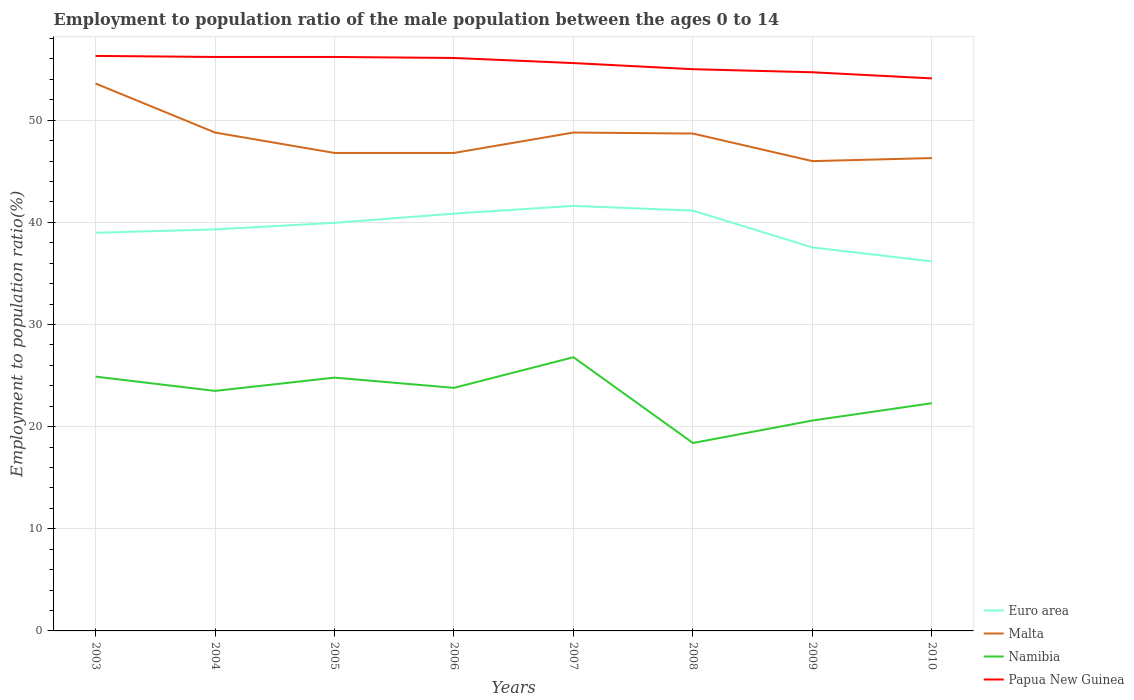Does the line corresponding to Euro area intersect with the line corresponding to Namibia?
Your answer should be compact. No. Across all years, what is the maximum employment to population ratio in Euro area?
Ensure brevity in your answer.  36.18. In which year was the employment to population ratio in Euro area maximum?
Keep it short and to the point. 2010. What is the total employment to population ratio in Papua New Guinea in the graph?
Keep it short and to the point. 0.1. What is the difference between the highest and the second highest employment to population ratio in Malta?
Offer a very short reply. 7.6. How many years are there in the graph?
Ensure brevity in your answer.  8. What is the difference between two consecutive major ticks on the Y-axis?
Your response must be concise. 10. Are the values on the major ticks of Y-axis written in scientific E-notation?
Offer a terse response. No. Does the graph contain grids?
Your answer should be very brief. Yes. How many legend labels are there?
Offer a terse response. 4. How are the legend labels stacked?
Offer a very short reply. Vertical. What is the title of the graph?
Provide a succinct answer. Employment to population ratio of the male population between the ages 0 to 14. What is the label or title of the X-axis?
Keep it short and to the point. Years. What is the label or title of the Y-axis?
Your answer should be compact. Employment to population ratio(%). What is the Employment to population ratio(%) in Euro area in 2003?
Provide a succinct answer. 38.98. What is the Employment to population ratio(%) in Malta in 2003?
Your answer should be very brief. 53.6. What is the Employment to population ratio(%) of Namibia in 2003?
Offer a terse response. 24.9. What is the Employment to population ratio(%) in Papua New Guinea in 2003?
Make the answer very short. 56.3. What is the Employment to population ratio(%) of Euro area in 2004?
Keep it short and to the point. 39.31. What is the Employment to population ratio(%) of Malta in 2004?
Provide a succinct answer. 48.8. What is the Employment to population ratio(%) of Namibia in 2004?
Provide a succinct answer. 23.5. What is the Employment to population ratio(%) in Papua New Guinea in 2004?
Your answer should be compact. 56.2. What is the Employment to population ratio(%) in Euro area in 2005?
Ensure brevity in your answer.  39.96. What is the Employment to population ratio(%) of Malta in 2005?
Your answer should be very brief. 46.8. What is the Employment to population ratio(%) in Namibia in 2005?
Your answer should be very brief. 24.8. What is the Employment to population ratio(%) of Papua New Guinea in 2005?
Your response must be concise. 56.2. What is the Employment to population ratio(%) of Euro area in 2006?
Your answer should be very brief. 40.86. What is the Employment to population ratio(%) in Malta in 2006?
Provide a short and direct response. 46.8. What is the Employment to population ratio(%) in Namibia in 2006?
Make the answer very short. 23.8. What is the Employment to population ratio(%) of Papua New Guinea in 2006?
Your response must be concise. 56.1. What is the Employment to population ratio(%) in Euro area in 2007?
Your answer should be very brief. 41.62. What is the Employment to population ratio(%) in Malta in 2007?
Provide a succinct answer. 48.8. What is the Employment to population ratio(%) of Namibia in 2007?
Offer a very short reply. 26.8. What is the Employment to population ratio(%) of Papua New Guinea in 2007?
Your response must be concise. 55.6. What is the Employment to population ratio(%) of Euro area in 2008?
Give a very brief answer. 41.15. What is the Employment to population ratio(%) of Malta in 2008?
Give a very brief answer. 48.7. What is the Employment to population ratio(%) in Namibia in 2008?
Give a very brief answer. 18.4. What is the Employment to population ratio(%) of Euro area in 2009?
Your answer should be compact. 37.55. What is the Employment to population ratio(%) in Namibia in 2009?
Offer a terse response. 20.6. What is the Employment to population ratio(%) of Papua New Guinea in 2009?
Provide a succinct answer. 54.7. What is the Employment to population ratio(%) in Euro area in 2010?
Your response must be concise. 36.18. What is the Employment to population ratio(%) in Malta in 2010?
Make the answer very short. 46.3. What is the Employment to population ratio(%) in Namibia in 2010?
Provide a succinct answer. 22.3. What is the Employment to population ratio(%) of Papua New Guinea in 2010?
Offer a terse response. 54.1. Across all years, what is the maximum Employment to population ratio(%) in Euro area?
Offer a terse response. 41.62. Across all years, what is the maximum Employment to population ratio(%) of Malta?
Your response must be concise. 53.6. Across all years, what is the maximum Employment to population ratio(%) in Namibia?
Ensure brevity in your answer.  26.8. Across all years, what is the maximum Employment to population ratio(%) of Papua New Guinea?
Provide a succinct answer. 56.3. Across all years, what is the minimum Employment to population ratio(%) in Euro area?
Your response must be concise. 36.18. Across all years, what is the minimum Employment to population ratio(%) in Malta?
Keep it short and to the point. 46. Across all years, what is the minimum Employment to population ratio(%) of Namibia?
Provide a succinct answer. 18.4. Across all years, what is the minimum Employment to population ratio(%) of Papua New Guinea?
Make the answer very short. 54.1. What is the total Employment to population ratio(%) in Euro area in the graph?
Provide a succinct answer. 315.61. What is the total Employment to population ratio(%) of Malta in the graph?
Provide a succinct answer. 385.8. What is the total Employment to population ratio(%) in Namibia in the graph?
Make the answer very short. 185.1. What is the total Employment to population ratio(%) of Papua New Guinea in the graph?
Give a very brief answer. 444.2. What is the difference between the Employment to population ratio(%) of Euro area in 2003 and that in 2004?
Make the answer very short. -0.33. What is the difference between the Employment to population ratio(%) of Malta in 2003 and that in 2004?
Offer a very short reply. 4.8. What is the difference between the Employment to population ratio(%) in Papua New Guinea in 2003 and that in 2004?
Offer a terse response. 0.1. What is the difference between the Employment to population ratio(%) of Euro area in 2003 and that in 2005?
Offer a very short reply. -0.97. What is the difference between the Employment to population ratio(%) of Malta in 2003 and that in 2005?
Make the answer very short. 6.8. What is the difference between the Employment to population ratio(%) of Namibia in 2003 and that in 2005?
Give a very brief answer. 0.1. What is the difference between the Employment to population ratio(%) of Euro area in 2003 and that in 2006?
Offer a very short reply. -1.88. What is the difference between the Employment to population ratio(%) in Papua New Guinea in 2003 and that in 2006?
Your answer should be compact. 0.2. What is the difference between the Employment to population ratio(%) of Euro area in 2003 and that in 2007?
Your response must be concise. -2.63. What is the difference between the Employment to population ratio(%) of Namibia in 2003 and that in 2007?
Offer a terse response. -1.9. What is the difference between the Employment to population ratio(%) of Euro area in 2003 and that in 2008?
Offer a very short reply. -2.17. What is the difference between the Employment to population ratio(%) in Papua New Guinea in 2003 and that in 2008?
Offer a very short reply. 1.3. What is the difference between the Employment to population ratio(%) of Euro area in 2003 and that in 2009?
Keep it short and to the point. 1.44. What is the difference between the Employment to population ratio(%) in Namibia in 2003 and that in 2009?
Your response must be concise. 4.3. What is the difference between the Employment to population ratio(%) of Papua New Guinea in 2003 and that in 2009?
Your answer should be compact. 1.6. What is the difference between the Employment to population ratio(%) in Euro area in 2003 and that in 2010?
Ensure brevity in your answer.  2.8. What is the difference between the Employment to population ratio(%) of Namibia in 2003 and that in 2010?
Your response must be concise. 2.6. What is the difference between the Employment to population ratio(%) in Euro area in 2004 and that in 2005?
Ensure brevity in your answer.  -0.64. What is the difference between the Employment to population ratio(%) in Malta in 2004 and that in 2005?
Give a very brief answer. 2. What is the difference between the Employment to population ratio(%) of Namibia in 2004 and that in 2005?
Your answer should be very brief. -1.3. What is the difference between the Employment to population ratio(%) of Papua New Guinea in 2004 and that in 2005?
Provide a succinct answer. 0. What is the difference between the Employment to population ratio(%) of Euro area in 2004 and that in 2006?
Your response must be concise. -1.55. What is the difference between the Employment to population ratio(%) of Malta in 2004 and that in 2006?
Keep it short and to the point. 2. What is the difference between the Employment to population ratio(%) of Namibia in 2004 and that in 2006?
Your answer should be compact. -0.3. What is the difference between the Employment to population ratio(%) in Euro area in 2004 and that in 2007?
Offer a very short reply. -2.3. What is the difference between the Employment to population ratio(%) in Malta in 2004 and that in 2007?
Offer a terse response. 0. What is the difference between the Employment to population ratio(%) in Namibia in 2004 and that in 2007?
Ensure brevity in your answer.  -3.3. What is the difference between the Employment to population ratio(%) of Papua New Guinea in 2004 and that in 2007?
Your response must be concise. 0.6. What is the difference between the Employment to population ratio(%) in Euro area in 2004 and that in 2008?
Offer a terse response. -1.84. What is the difference between the Employment to population ratio(%) in Namibia in 2004 and that in 2008?
Make the answer very short. 5.1. What is the difference between the Employment to population ratio(%) of Euro area in 2004 and that in 2009?
Your response must be concise. 1.77. What is the difference between the Employment to population ratio(%) in Malta in 2004 and that in 2009?
Provide a short and direct response. 2.8. What is the difference between the Employment to population ratio(%) of Papua New Guinea in 2004 and that in 2009?
Make the answer very short. 1.5. What is the difference between the Employment to population ratio(%) of Euro area in 2004 and that in 2010?
Provide a short and direct response. 3.13. What is the difference between the Employment to population ratio(%) of Namibia in 2004 and that in 2010?
Your answer should be compact. 1.2. What is the difference between the Employment to population ratio(%) in Euro area in 2005 and that in 2006?
Give a very brief answer. -0.9. What is the difference between the Employment to population ratio(%) in Namibia in 2005 and that in 2006?
Provide a short and direct response. 1. What is the difference between the Employment to population ratio(%) in Euro area in 2005 and that in 2007?
Offer a very short reply. -1.66. What is the difference between the Employment to population ratio(%) of Euro area in 2005 and that in 2008?
Offer a terse response. -1.2. What is the difference between the Employment to population ratio(%) of Malta in 2005 and that in 2008?
Offer a terse response. -1.9. What is the difference between the Employment to population ratio(%) in Namibia in 2005 and that in 2008?
Make the answer very short. 6.4. What is the difference between the Employment to population ratio(%) of Euro area in 2005 and that in 2009?
Provide a short and direct response. 2.41. What is the difference between the Employment to population ratio(%) in Malta in 2005 and that in 2009?
Give a very brief answer. 0.8. What is the difference between the Employment to population ratio(%) in Euro area in 2005 and that in 2010?
Offer a terse response. 3.78. What is the difference between the Employment to population ratio(%) in Euro area in 2006 and that in 2007?
Ensure brevity in your answer.  -0.76. What is the difference between the Employment to population ratio(%) in Malta in 2006 and that in 2007?
Ensure brevity in your answer.  -2. What is the difference between the Employment to population ratio(%) in Papua New Guinea in 2006 and that in 2007?
Provide a short and direct response. 0.5. What is the difference between the Employment to population ratio(%) in Euro area in 2006 and that in 2008?
Keep it short and to the point. -0.29. What is the difference between the Employment to population ratio(%) of Malta in 2006 and that in 2008?
Your answer should be compact. -1.9. What is the difference between the Employment to population ratio(%) of Namibia in 2006 and that in 2008?
Offer a terse response. 5.4. What is the difference between the Employment to population ratio(%) of Euro area in 2006 and that in 2009?
Your response must be concise. 3.31. What is the difference between the Employment to population ratio(%) in Namibia in 2006 and that in 2009?
Your answer should be very brief. 3.2. What is the difference between the Employment to population ratio(%) in Euro area in 2006 and that in 2010?
Offer a terse response. 4.68. What is the difference between the Employment to population ratio(%) of Malta in 2006 and that in 2010?
Provide a short and direct response. 0.5. What is the difference between the Employment to population ratio(%) of Namibia in 2006 and that in 2010?
Offer a very short reply. 1.5. What is the difference between the Employment to population ratio(%) in Euro area in 2007 and that in 2008?
Offer a very short reply. 0.46. What is the difference between the Employment to population ratio(%) in Namibia in 2007 and that in 2008?
Provide a short and direct response. 8.4. What is the difference between the Employment to population ratio(%) in Euro area in 2007 and that in 2009?
Keep it short and to the point. 4.07. What is the difference between the Employment to population ratio(%) of Papua New Guinea in 2007 and that in 2009?
Provide a succinct answer. 0.9. What is the difference between the Employment to population ratio(%) in Euro area in 2007 and that in 2010?
Your response must be concise. 5.44. What is the difference between the Employment to population ratio(%) of Malta in 2007 and that in 2010?
Make the answer very short. 2.5. What is the difference between the Employment to population ratio(%) in Papua New Guinea in 2007 and that in 2010?
Your answer should be very brief. 1.5. What is the difference between the Employment to population ratio(%) in Euro area in 2008 and that in 2009?
Ensure brevity in your answer.  3.61. What is the difference between the Employment to population ratio(%) in Malta in 2008 and that in 2009?
Your answer should be compact. 2.7. What is the difference between the Employment to population ratio(%) in Namibia in 2008 and that in 2009?
Make the answer very short. -2.2. What is the difference between the Employment to population ratio(%) in Papua New Guinea in 2008 and that in 2009?
Your answer should be compact. 0.3. What is the difference between the Employment to population ratio(%) in Euro area in 2008 and that in 2010?
Offer a terse response. 4.97. What is the difference between the Employment to population ratio(%) of Malta in 2008 and that in 2010?
Ensure brevity in your answer.  2.4. What is the difference between the Employment to population ratio(%) of Papua New Guinea in 2008 and that in 2010?
Your answer should be very brief. 0.9. What is the difference between the Employment to population ratio(%) in Euro area in 2009 and that in 2010?
Provide a succinct answer. 1.37. What is the difference between the Employment to population ratio(%) of Euro area in 2003 and the Employment to population ratio(%) of Malta in 2004?
Ensure brevity in your answer.  -9.82. What is the difference between the Employment to population ratio(%) of Euro area in 2003 and the Employment to population ratio(%) of Namibia in 2004?
Your answer should be compact. 15.48. What is the difference between the Employment to population ratio(%) of Euro area in 2003 and the Employment to population ratio(%) of Papua New Guinea in 2004?
Your answer should be compact. -17.22. What is the difference between the Employment to population ratio(%) in Malta in 2003 and the Employment to population ratio(%) in Namibia in 2004?
Make the answer very short. 30.1. What is the difference between the Employment to population ratio(%) in Namibia in 2003 and the Employment to population ratio(%) in Papua New Guinea in 2004?
Offer a terse response. -31.3. What is the difference between the Employment to population ratio(%) in Euro area in 2003 and the Employment to population ratio(%) in Malta in 2005?
Give a very brief answer. -7.82. What is the difference between the Employment to population ratio(%) in Euro area in 2003 and the Employment to population ratio(%) in Namibia in 2005?
Provide a short and direct response. 14.18. What is the difference between the Employment to population ratio(%) of Euro area in 2003 and the Employment to population ratio(%) of Papua New Guinea in 2005?
Make the answer very short. -17.22. What is the difference between the Employment to population ratio(%) of Malta in 2003 and the Employment to population ratio(%) of Namibia in 2005?
Offer a terse response. 28.8. What is the difference between the Employment to population ratio(%) of Malta in 2003 and the Employment to population ratio(%) of Papua New Guinea in 2005?
Provide a succinct answer. -2.6. What is the difference between the Employment to population ratio(%) in Namibia in 2003 and the Employment to population ratio(%) in Papua New Guinea in 2005?
Your answer should be very brief. -31.3. What is the difference between the Employment to population ratio(%) in Euro area in 2003 and the Employment to population ratio(%) in Malta in 2006?
Offer a very short reply. -7.82. What is the difference between the Employment to population ratio(%) in Euro area in 2003 and the Employment to population ratio(%) in Namibia in 2006?
Your answer should be compact. 15.18. What is the difference between the Employment to population ratio(%) of Euro area in 2003 and the Employment to population ratio(%) of Papua New Guinea in 2006?
Offer a terse response. -17.12. What is the difference between the Employment to population ratio(%) in Malta in 2003 and the Employment to population ratio(%) in Namibia in 2006?
Your answer should be compact. 29.8. What is the difference between the Employment to population ratio(%) in Malta in 2003 and the Employment to population ratio(%) in Papua New Guinea in 2006?
Make the answer very short. -2.5. What is the difference between the Employment to population ratio(%) of Namibia in 2003 and the Employment to population ratio(%) of Papua New Guinea in 2006?
Ensure brevity in your answer.  -31.2. What is the difference between the Employment to population ratio(%) of Euro area in 2003 and the Employment to population ratio(%) of Malta in 2007?
Offer a very short reply. -9.82. What is the difference between the Employment to population ratio(%) of Euro area in 2003 and the Employment to population ratio(%) of Namibia in 2007?
Make the answer very short. 12.18. What is the difference between the Employment to population ratio(%) in Euro area in 2003 and the Employment to population ratio(%) in Papua New Guinea in 2007?
Your answer should be compact. -16.62. What is the difference between the Employment to population ratio(%) in Malta in 2003 and the Employment to population ratio(%) in Namibia in 2007?
Your answer should be very brief. 26.8. What is the difference between the Employment to population ratio(%) in Namibia in 2003 and the Employment to population ratio(%) in Papua New Guinea in 2007?
Give a very brief answer. -30.7. What is the difference between the Employment to population ratio(%) in Euro area in 2003 and the Employment to population ratio(%) in Malta in 2008?
Ensure brevity in your answer.  -9.72. What is the difference between the Employment to population ratio(%) in Euro area in 2003 and the Employment to population ratio(%) in Namibia in 2008?
Offer a very short reply. 20.58. What is the difference between the Employment to population ratio(%) in Euro area in 2003 and the Employment to population ratio(%) in Papua New Guinea in 2008?
Your answer should be very brief. -16.02. What is the difference between the Employment to population ratio(%) in Malta in 2003 and the Employment to population ratio(%) in Namibia in 2008?
Make the answer very short. 35.2. What is the difference between the Employment to population ratio(%) in Namibia in 2003 and the Employment to population ratio(%) in Papua New Guinea in 2008?
Provide a short and direct response. -30.1. What is the difference between the Employment to population ratio(%) of Euro area in 2003 and the Employment to population ratio(%) of Malta in 2009?
Give a very brief answer. -7.02. What is the difference between the Employment to population ratio(%) in Euro area in 2003 and the Employment to population ratio(%) in Namibia in 2009?
Offer a terse response. 18.38. What is the difference between the Employment to population ratio(%) of Euro area in 2003 and the Employment to population ratio(%) of Papua New Guinea in 2009?
Make the answer very short. -15.72. What is the difference between the Employment to population ratio(%) of Malta in 2003 and the Employment to population ratio(%) of Namibia in 2009?
Ensure brevity in your answer.  33. What is the difference between the Employment to population ratio(%) in Namibia in 2003 and the Employment to population ratio(%) in Papua New Guinea in 2009?
Ensure brevity in your answer.  -29.8. What is the difference between the Employment to population ratio(%) in Euro area in 2003 and the Employment to population ratio(%) in Malta in 2010?
Provide a succinct answer. -7.32. What is the difference between the Employment to population ratio(%) of Euro area in 2003 and the Employment to population ratio(%) of Namibia in 2010?
Ensure brevity in your answer.  16.68. What is the difference between the Employment to population ratio(%) of Euro area in 2003 and the Employment to population ratio(%) of Papua New Guinea in 2010?
Your answer should be compact. -15.12. What is the difference between the Employment to population ratio(%) in Malta in 2003 and the Employment to population ratio(%) in Namibia in 2010?
Offer a terse response. 31.3. What is the difference between the Employment to population ratio(%) of Namibia in 2003 and the Employment to population ratio(%) of Papua New Guinea in 2010?
Give a very brief answer. -29.2. What is the difference between the Employment to population ratio(%) in Euro area in 2004 and the Employment to population ratio(%) in Malta in 2005?
Your answer should be very brief. -7.49. What is the difference between the Employment to population ratio(%) in Euro area in 2004 and the Employment to population ratio(%) in Namibia in 2005?
Provide a short and direct response. 14.52. What is the difference between the Employment to population ratio(%) in Euro area in 2004 and the Employment to population ratio(%) in Papua New Guinea in 2005?
Offer a terse response. -16.89. What is the difference between the Employment to population ratio(%) in Malta in 2004 and the Employment to population ratio(%) in Papua New Guinea in 2005?
Provide a succinct answer. -7.4. What is the difference between the Employment to population ratio(%) of Namibia in 2004 and the Employment to population ratio(%) of Papua New Guinea in 2005?
Ensure brevity in your answer.  -32.7. What is the difference between the Employment to population ratio(%) of Euro area in 2004 and the Employment to population ratio(%) of Malta in 2006?
Offer a terse response. -7.49. What is the difference between the Employment to population ratio(%) in Euro area in 2004 and the Employment to population ratio(%) in Namibia in 2006?
Make the answer very short. 15.52. What is the difference between the Employment to population ratio(%) of Euro area in 2004 and the Employment to population ratio(%) of Papua New Guinea in 2006?
Provide a short and direct response. -16.79. What is the difference between the Employment to population ratio(%) of Malta in 2004 and the Employment to population ratio(%) of Namibia in 2006?
Offer a very short reply. 25. What is the difference between the Employment to population ratio(%) of Malta in 2004 and the Employment to population ratio(%) of Papua New Guinea in 2006?
Your answer should be very brief. -7.3. What is the difference between the Employment to population ratio(%) of Namibia in 2004 and the Employment to population ratio(%) of Papua New Guinea in 2006?
Your answer should be compact. -32.6. What is the difference between the Employment to population ratio(%) in Euro area in 2004 and the Employment to population ratio(%) in Malta in 2007?
Give a very brief answer. -9.48. What is the difference between the Employment to population ratio(%) of Euro area in 2004 and the Employment to population ratio(%) of Namibia in 2007?
Offer a terse response. 12.52. What is the difference between the Employment to population ratio(%) of Euro area in 2004 and the Employment to population ratio(%) of Papua New Guinea in 2007?
Offer a very short reply. -16.29. What is the difference between the Employment to population ratio(%) of Namibia in 2004 and the Employment to population ratio(%) of Papua New Guinea in 2007?
Give a very brief answer. -32.1. What is the difference between the Employment to population ratio(%) of Euro area in 2004 and the Employment to population ratio(%) of Malta in 2008?
Ensure brevity in your answer.  -9.38. What is the difference between the Employment to population ratio(%) of Euro area in 2004 and the Employment to population ratio(%) of Namibia in 2008?
Provide a succinct answer. 20.91. What is the difference between the Employment to population ratio(%) in Euro area in 2004 and the Employment to population ratio(%) in Papua New Guinea in 2008?
Provide a succinct answer. -15.69. What is the difference between the Employment to population ratio(%) in Malta in 2004 and the Employment to population ratio(%) in Namibia in 2008?
Your response must be concise. 30.4. What is the difference between the Employment to population ratio(%) in Malta in 2004 and the Employment to population ratio(%) in Papua New Guinea in 2008?
Your answer should be compact. -6.2. What is the difference between the Employment to population ratio(%) in Namibia in 2004 and the Employment to population ratio(%) in Papua New Guinea in 2008?
Offer a very short reply. -31.5. What is the difference between the Employment to population ratio(%) in Euro area in 2004 and the Employment to population ratio(%) in Malta in 2009?
Offer a terse response. -6.68. What is the difference between the Employment to population ratio(%) of Euro area in 2004 and the Employment to population ratio(%) of Namibia in 2009?
Give a very brief answer. 18.71. What is the difference between the Employment to population ratio(%) in Euro area in 2004 and the Employment to population ratio(%) in Papua New Guinea in 2009?
Your response must be concise. -15.38. What is the difference between the Employment to population ratio(%) in Malta in 2004 and the Employment to population ratio(%) in Namibia in 2009?
Your answer should be very brief. 28.2. What is the difference between the Employment to population ratio(%) in Malta in 2004 and the Employment to population ratio(%) in Papua New Guinea in 2009?
Your response must be concise. -5.9. What is the difference between the Employment to population ratio(%) of Namibia in 2004 and the Employment to population ratio(%) of Papua New Guinea in 2009?
Make the answer very short. -31.2. What is the difference between the Employment to population ratio(%) in Euro area in 2004 and the Employment to population ratio(%) in Malta in 2010?
Offer a terse response. -6.99. What is the difference between the Employment to population ratio(%) in Euro area in 2004 and the Employment to population ratio(%) in Namibia in 2010?
Make the answer very short. 17.02. What is the difference between the Employment to population ratio(%) in Euro area in 2004 and the Employment to population ratio(%) in Papua New Guinea in 2010?
Keep it short and to the point. -14.79. What is the difference between the Employment to population ratio(%) of Malta in 2004 and the Employment to population ratio(%) of Namibia in 2010?
Offer a terse response. 26.5. What is the difference between the Employment to population ratio(%) of Malta in 2004 and the Employment to population ratio(%) of Papua New Guinea in 2010?
Offer a terse response. -5.3. What is the difference between the Employment to population ratio(%) in Namibia in 2004 and the Employment to population ratio(%) in Papua New Guinea in 2010?
Provide a succinct answer. -30.6. What is the difference between the Employment to population ratio(%) of Euro area in 2005 and the Employment to population ratio(%) of Malta in 2006?
Your response must be concise. -6.84. What is the difference between the Employment to population ratio(%) of Euro area in 2005 and the Employment to population ratio(%) of Namibia in 2006?
Ensure brevity in your answer.  16.16. What is the difference between the Employment to population ratio(%) of Euro area in 2005 and the Employment to population ratio(%) of Papua New Guinea in 2006?
Give a very brief answer. -16.14. What is the difference between the Employment to population ratio(%) in Malta in 2005 and the Employment to population ratio(%) in Papua New Guinea in 2006?
Your answer should be compact. -9.3. What is the difference between the Employment to population ratio(%) of Namibia in 2005 and the Employment to population ratio(%) of Papua New Guinea in 2006?
Your answer should be very brief. -31.3. What is the difference between the Employment to population ratio(%) in Euro area in 2005 and the Employment to population ratio(%) in Malta in 2007?
Ensure brevity in your answer.  -8.84. What is the difference between the Employment to population ratio(%) in Euro area in 2005 and the Employment to population ratio(%) in Namibia in 2007?
Offer a terse response. 13.16. What is the difference between the Employment to population ratio(%) of Euro area in 2005 and the Employment to population ratio(%) of Papua New Guinea in 2007?
Your answer should be very brief. -15.64. What is the difference between the Employment to population ratio(%) in Namibia in 2005 and the Employment to population ratio(%) in Papua New Guinea in 2007?
Offer a very short reply. -30.8. What is the difference between the Employment to population ratio(%) in Euro area in 2005 and the Employment to population ratio(%) in Malta in 2008?
Your response must be concise. -8.74. What is the difference between the Employment to population ratio(%) of Euro area in 2005 and the Employment to population ratio(%) of Namibia in 2008?
Make the answer very short. 21.56. What is the difference between the Employment to population ratio(%) of Euro area in 2005 and the Employment to population ratio(%) of Papua New Guinea in 2008?
Give a very brief answer. -15.04. What is the difference between the Employment to population ratio(%) in Malta in 2005 and the Employment to population ratio(%) in Namibia in 2008?
Offer a very short reply. 28.4. What is the difference between the Employment to population ratio(%) of Malta in 2005 and the Employment to population ratio(%) of Papua New Guinea in 2008?
Provide a succinct answer. -8.2. What is the difference between the Employment to population ratio(%) in Namibia in 2005 and the Employment to population ratio(%) in Papua New Guinea in 2008?
Your answer should be compact. -30.2. What is the difference between the Employment to population ratio(%) in Euro area in 2005 and the Employment to population ratio(%) in Malta in 2009?
Provide a short and direct response. -6.04. What is the difference between the Employment to population ratio(%) of Euro area in 2005 and the Employment to population ratio(%) of Namibia in 2009?
Make the answer very short. 19.36. What is the difference between the Employment to population ratio(%) in Euro area in 2005 and the Employment to population ratio(%) in Papua New Guinea in 2009?
Ensure brevity in your answer.  -14.74. What is the difference between the Employment to population ratio(%) in Malta in 2005 and the Employment to population ratio(%) in Namibia in 2009?
Your answer should be very brief. 26.2. What is the difference between the Employment to population ratio(%) of Namibia in 2005 and the Employment to population ratio(%) of Papua New Guinea in 2009?
Give a very brief answer. -29.9. What is the difference between the Employment to population ratio(%) in Euro area in 2005 and the Employment to population ratio(%) in Malta in 2010?
Your answer should be compact. -6.34. What is the difference between the Employment to population ratio(%) of Euro area in 2005 and the Employment to population ratio(%) of Namibia in 2010?
Make the answer very short. 17.66. What is the difference between the Employment to population ratio(%) in Euro area in 2005 and the Employment to population ratio(%) in Papua New Guinea in 2010?
Provide a succinct answer. -14.14. What is the difference between the Employment to population ratio(%) of Namibia in 2005 and the Employment to population ratio(%) of Papua New Guinea in 2010?
Keep it short and to the point. -29.3. What is the difference between the Employment to population ratio(%) of Euro area in 2006 and the Employment to population ratio(%) of Malta in 2007?
Offer a terse response. -7.94. What is the difference between the Employment to population ratio(%) in Euro area in 2006 and the Employment to population ratio(%) in Namibia in 2007?
Give a very brief answer. 14.06. What is the difference between the Employment to population ratio(%) of Euro area in 2006 and the Employment to population ratio(%) of Papua New Guinea in 2007?
Offer a terse response. -14.74. What is the difference between the Employment to population ratio(%) of Malta in 2006 and the Employment to population ratio(%) of Namibia in 2007?
Provide a succinct answer. 20. What is the difference between the Employment to population ratio(%) of Malta in 2006 and the Employment to population ratio(%) of Papua New Guinea in 2007?
Offer a very short reply. -8.8. What is the difference between the Employment to population ratio(%) of Namibia in 2006 and the Employment to population ratio(%) of Papua New Guinea in 2007?
Your response must be concise. -31.8. What is the difference between the Employment to population ratio(%) of Euro area in 2006 and the Employment to population ratio(%) of Malta in 2008?
Provide a short and direct response. -7.84. What is the difference between the Employment to population ratio(%) in Euro area in 2006 and the Employment to population ratio(%) in Namibia in 2008?
Make the answer very short. 22.46. What is the difference between the Employment to population ratio(%) in Euro area in 2006 and the Employment to population ratio(%) in Papua New Guinea in 2008?
Make the answer very short. -14.14. What is the difference between the Employment to population ratio(%) of Malta in 2006 and the Employment to population ratio(%) of Namibia in 2008?
Provide a short and direct response. 28.4. What is the difference between the Employment to population ratio(%) in Namibia in 2006 and the Employment to population ratio(%) in Papua New Guinea in 2008?
Keep it short and to the point. -31.2. What is the difference between the Employment to population ratio(%) in Euro area in 2006 and the Employment to population ratio(%) in Malta in 2009?
Ensure brevity in your answer.  -5.14. What is the difference between the Employment to population ratio(%) in Euro area in 2006 and the Employment to population ratio(%) in Namibia in 2009?
Ensure brevity in your answer.  20.26. What is the difference between the Employment to population ratio(%) in Euro area in 2006 and the Employment to population ratio(%) in Papua New Guinea in 2009?
Offer a terse response. -13.84. What is the difference between the Employment to population ratio(%) of Malta in 2006 and the Employment to population ratio(%) of Namibia in 2009?
Make the answer very short. 26.2. What is the difference between the Employment to population ratio(%) in Namibia in 2006 and the Employment to population ratio(%) in Papua New Guinea in 2009?
Give a very brief answer. -30.9. What is the difference between the Employment to population ratio(%) of Euro area in 2006 and the Employment to population ratio(%) of Malta in 2010?
Your answer should be compact. -5.44. What is the difference between the Employment to population ratio(%) in Euro area in 2006 and the Employment to population ratio(%) in Namibia in 2010?
Offer a terse response. 18.56. What is the difference between the Employment to population ratio(%) in Euro area in 2006 and the Employment to population ratio(%) in Papua New Guinea in 2010?
Provide a short and direct response. -13.24. What is the difference between the Employment to population ratio(%) of Malta in 2006 and the Employment to population ratio(%) of Papua New Guinea in 2010?
Your answer should be very brief. -7.3. What is the difference between the Employment to population ratio(%) of Namibia in 2006 and the Employment to population ratio(%) of Papua New Guinea in 2010?
Ensure brevity in your answer.  -30.3. What is the difference between the Employment to population ratio(%) of Euro area in 2007 and the Employment to population ratio(%) of Malta in 2008?
Ensure brevity in your answer.  -7.08. What is the difference between the Employment to population ratio(%) in Euro area in 2007 and the Employment to population ratio(%) in Namibia in 2008?
Offer a terse response. 23.22. What is the difference between the Employment to population ratio(%) in Euro area in 2007 and the Employment to population ratio(%) in Papua New Guinea in 2008?
Provide a succinct answer. -13.38. What is the difference between the Employment to population ratio(%) in Malta in 2007 and the Employment to population ratio(%) in Namibia in 2008?
Provide a short and direct response. 30.4. What is the difference between the Employment to population ratio(%) of Namibia in 2007 and the Employment to population ratio(%) of Papua New Guinea in 2008?
Your response must be concise. -28.2. What is the difference between the Employment to population ratio(%) of Euro area in 2007 and the Employment to population ratio(%) of Malta in 2009?
Your response must be concise. -4.38. What is the difference between the Employment to population ratio(%) in Euro area in 2007 and the Employment to population ratio(%) in Namibia in 2009?
Ensure brevity in your answer.  21.02. What is the difference between the Employment to population ratio(%) in Euro area in 2007 and the Employment to population ratio(%) in Papua New Guinea in 2009?
Provide a succinct answer. -13.08. What is the difference between the Employment to population ratio(%) of Malta in 2007 and the Employment to population ratio(%) of Namibia in 2009?
Offer a very short reply. 28.2. What is the difference between the Employment to population ratio(%) in Namibia in 2007 and the Employment to population ratio(%) in Papua New Guinea in 2009?
Your response must be concise. -27.9. What is the difference between the Employment to population ratio(%) of Euro area in 2007 and the Employment to population ratio(%) of Malta in 2010?
Keep it short and to the point. -4.68. What is the difference between the Employment to population ratio(%) in Euro area in 2007 and the Employment to population ratio(%) in Namibia in 2010?
Give a very brief answer. 19.32. What is the difference between the Employment to population ratio(%) of Euro area in 2007 and the Employment to population ratio(%) of Papua New Guinea in 2010?
Your answer should be very brief. -12.48. What is the difference between the Employment to population ratio(%) of Malta in 2007 and the Employment to population ratio(%) of Namibia in 2010?
Your answer should be very brief. 26.5. What is the difference between the Employment to population ratio(%) of Malta in 2007 and the Employment to population ratio(%) of Papua New Guinea in 2010?
Provide a short and direct response. -5.3. What is the difference between the Employment to population ratio(%) of Namibia in 2007 and the Employment to population ratio(%) of Papua New Guinea in 2010?
Provide a succinct answer. -27.3. What is the difference between the Employment to population ratio(%) of Euro area in 2008 and the Employment to population ratio(%) of Malta in 2009?
Give a very brief answer. -4.85. What is the difference between the Employment to population ratio(%) of Euro area in 2008 and the Employment to population ratio(%) of Namibia in 2009?
Provide a succinct answer. 20.55. What is the difference between the Employment to population ratio(%) of Euro area in 2008 and the Employment to population ratio(%) of Papua New Guinea in 2009?
Ensure brevity in your answer.  -13.55. What is the difference between the Employment to population ratio(%) of Malta in 2008 and the Employment to population ratio(%) of Namibia in 2009?
Give a very brief answer. 28.1. What is the difference between the Employment to population ratio(%) of Malta in 2008 and the Employment to population ratio(%) of Papua New Guinea in 2009?
Your answer should be compact. -6. What is the difference between the Employment to population ratio(%) in Namibia in 2008 and the Employment to population ratio(%) in Papua New Guinea in 2009?
Provide a succinct answer. -36.3. What is the difference between the Employment to population ratio(%) of Euro area in 2008 and the Employment to population ratio(%) of Malta in 2010?
Offer a very short reply. -5.15. What is the difference between the Employment to population ratio(%) in Euro area in 2008 and the Employment to population ratio(%) in Namibia in 2010?
Your answer should be compact. 18.85. What is the difference between the Employment to population ratio(%) in Euro area in 2008 and the Employment to population ratio(%) in Papua New Guinea in 2010?
Your response must be concise. -12.95. What is the difference between the Employment to population ratio(%) of Malta in 2008 and the Employment to population ratio(%) of Namibia in 2010?
Your response must be concise. 26.4. What is the difference between the Employment to population ratio(%) of Malta in 2008 and the Employment to population ratio(%) of Papua New Guinea in 2010?
Offer a very short reply. -5.4. What is the difference between the Employment to population ratio(%) in Namibia in 2008 and the Employment to population ratio(%) in Papua New Guinea in 2010?
Make the answer very short. -35.7. What is the difference between the Employment to population ratio(%) of Euro area in 2009 and the Employment to population ratio(%) of Malta in 2010?
Give a very brief answer. -8.75. What is the difference between the Employment to population ratio(%) of Euro area in 2009 and the Employment to population ratio(%) of Namibia in 2010?
Offer a very short reply. 15.25. What is the difference between the Employment to population ratio(%) of Euro area in 2009 and the Employment to population ratio(%) of Papua New Guinea in 2010?
Your answer should be compact. -16.55. What is the difference between the Employment to population ratio(%) in Malta in 2009 and the Employment to population ratio(%) in Namibia in 2010?
Your response must be concise. 23.7. What is the difference between the Employment to population ratio(%) of Namibia in 2009 and the Employment to population ratio(%) of Papua New Guinea in 2010?
Make the answer very short. -33.5. What is the average Employment to population ratio(%) in Euro area per year?
Make the answer very short. 39.45. What is the average Employment to population ratio(%) of Malta per year?
Your response must be concise. 48.23. What is the average Employment to population ratio(%) in Namibia per year?
Your response must be concise. 23.14. What is the average Employment to population ratio(%) in Papua New Guinea per year?
Keep it short and to the point. 55.52. In the year 2003, what is the difference between the Employment to population ratio(%) of Euro area and Employment to population ratio(%) of Malta?
Offer a very short reply. -14.62. In the year 2003, what is the difference between the Employment to population ratio(%) of Euro area and Employment to population ratio(%) of Namibia?
Make the answer very short. 14.08. In the year 2003, what is the difference between the Employment to population ratio(%) of Euro area and Employment to population ratio(%) of Papua New Guinea?
Give a very brief answer. -17.32. In the year 2003, what is the difference between the Employment to population ratio(%) of Malta and Employment to population ratio(%) of Namibia?
Your response must be concise. 28.7. In the year 2003, what is the difference between the Employment to population ratio(%) of Namibia and Employment to population ratio(%) of Papua New Guinea?
Your answer should be compact. -31.4. In the year 2004, what is the difference between the Employment to population ratio(%) of Euro area and Employment to population ratio(%) of Malta?
Your answer should be compact. -9.48. In the year 2004, what is the difference between the Employment to population ratio(%) in Euro area and Employment to population ratio(%) in Namibia?
Keep it short and to the point. 15.81. In the year 2004, what is the difference between the Employment to population ratio(%) of Euro area and Employment to population ratio(%) of Papua New Guinea?
Your answer should be very brief. -16.89. In the year 2004, what is the difference between the Employment to population ratio(%) in Malta and Employment to population ratio(%) in Namibia?
Offer a very short reply. 25.3. In the year 2004, what is the difference between the Employment to population ratio(%) of Namibia and Employment to population ratio(%) of Papua New Guinea?
Your answer should be compact. -32.7. In the year 2005, what is the difference between the Employment to population ratio(%) in Euro area and Employment to population ratio(%) in Malta?
Offer a terse response. -6.84. In the year 2005, what is the difference between the Employment to population ratio(%) of Euro area and Employment to population ratio(%) of Namibia?
Provide a short and direct response. 15.16. In the year 2005, what is the difference between the Employment to population ratio(%) in Euro area and Employment to population ratio(%) in Papua New Guinea?
Keep it short and to the point. -16.24. In the year 2005, what is the difference between the Employment to population ratio(%) in Namibia and Employment to population ratio(%) in Papua New Guinea?
Give a very brief answer. -31.4. In the year 2006, what is the difference between the Employment to population ratio(%) in Euro area and Employment to population ratio(%) in Malta?
Offer a very short reply. -5.94. In the year 2006, what is the difference between the Employment to population ratio(%) of Euro area and Employment to population ratio(%) of Namibia?
Your response must be concise. 17.06. In the year 2006, what is the difference between the Employment to population ratio(%) in Euro area and Employment to population ratio(%) in Papua New Guinea?
Offer a terse response. -15.24. In the year 2006, what is the difference between the Employment to population ratio(%) of Namibia and Employment to population ratio(%) of Papua New Guinea?
Offer a very short reply. -32.3. In the year 2007, what is the difference between the Employment to population ratio(%) in Euro area and Employment to population ratio(%) in Malta?
Keep it short and to the point. -7.18. In the year 2007, what is the difference between the Employment to population ratio(%) of Euro area and Employment to population ratio(%) of Namibia?
Offer a terse response. 14.82. In the year 2007, what is the difference between the Employment to population ratio(%) of Euro area and Employment to population ratio(%) of Papua New Guinea?
Give a very brief answer. -13.98. In the year 2007, what is the difference between the Employment to population ratio(%) of Namibia and Employment to population ratio(%) of Papua New Guinea?
Make the answer very short. -28.8. In the year 2008, what is the difference between the Employment to population ratio(%) of Euro area and Employment to population ratio(%) of Malta?
Provide a short and direct response. -7.55. In the year 2008, what is the difference between the Employment to population ratio(%) in Euro area and Employment to population ratio(%) in Namibia?
Keep it short and to the point. 22.75. In the year 2008, what is the difference between the Employment to population ratio(%) in Euro area and Employment to population ratio(%) in Papua New Guinea?
Offer a very short reply. -13.85. In the year 2008, what is the difference between the Employment to population ratio(%) in Malta and Employment to population ratio(%) in Namibia?
Your answer should be very brief. 30.3. In the year 2008, what is the difference between the Employment to population ratio(%) of Malta and Employment to population ratio(%) of Papua New Guinea?
Give a very brief answer. -6.3. In the year 2008, what is the difference between the Employment to population ratio(%) of Namibia and Employment to population ratio(%) of Papua New Guinea?
Offer a terse response. -36.6. In the year 2009, what is the difference between the Employment to population ratio(%) of Euro area and Employment to population ratio(%) of Malta?
Make the answer very short. -8.45. In the year 2009, what is the difference between the Employment to population ratio(%) of Euro area and Employment to population ratio(%) of Namibia?
Provide a succinct answer. 16.95. In the year 2009, what is the difference between the Employment to population ratio(%) in Euro area and Employment to population ratio(%) in Papua New Guinea?
Your answer should be compact. -17.15. In the year 2009, what is the difference between the Employment to population ratio(%) in Malta and Employment to population ratio(%) in Namibia?
Ensure brevity in your answer.  25.4. In the year 2009, what is the difference between the Employment to population ratio(%) in Malta and Employment to population ratio(%) in Papua New Guinea?
Offer a very short reply. -8.7. In the year 2009, what is the difference between the Employment to population ratio(%) of Namibia and Employment to population ratio(%) of Papua New Guinea?
Offer a very short reply. -34.1. In the year 2010, what is the difference between the Employment to population ratio(%) in Euro area and Employment to population ratio(%) in Malta?
Ensure brevity in your answer.  -10.12. In the year 2010, what is the difference between the Employment to population ratio(%) of Euro area and Employment to population ratio(%) of Namibia?
Offer a terse response. 13.88. In the year 2010, what is the difference between the Employment to population ratio(%) of Euro area and Employment to population ratio(%) of Papua New Guinea?
Offer a terse response. -17.92. In the year 2010, what is the difference between the Employment to population ratio(%) in Malta and Employment to population ratio(%) in Papua New Guinea?
Keep it short and to the point. -7.8. In the year 2010, what is the difference between the Employment to population ratio(%) of Namibia and Employment to population ratio(%) of Papua New Guinea?
Provide a succinct answer. -31.8. What is the ratio of the Employment to population ratio(%) of Malta in 2003 to that in 2004?
Keep it short and to the point. 1.1. What is the ratio of the Employment to population ratio(%) in Namibia in 2003 to that in 2004?
Offer a terse response. 1.06. What is the ratio of the Employment to population ratio(%) in Euro area in 2003 to that in 2005?
Provide a short and direct response. 0.98. What is the ratio of the Employment to population ratio(%) in Malta in 2003 to that in 2005?
Provide a short and direct response. 1.15. What is the ratio of the Employment to population ratio(%) in Euro area in 2003 to that in 2006?
Your answer should be compact. 0.95. What is the ratio of the Employment to population ratio(%) in Malta in 2003 to that in 2006?
Your response must be concise. 1.15. What is the ratio of the Employment to population ratio(%) of Namibia in 2003 to that in 2006?
Your response must be concise. 1.05. What is the ratio of the Employment to population ratio(%) in Papua New Guinea in 2003 to that in 2006?
Your answer should be very brief. 1. What is the ratio of the Employment to population ratio(%) of Euro area in 2003 to that in 2007?
Your answer should be very brief. 0.94. What is the ratio of the Employment to population ratio(%) of Malta in 2003 to that in 2007?
Make the answer very short. 1.1. What is the ratio of the Employment to population ratio(%) in Namibia in 2003 to that in 2007?
Give a very brief answer. 0.93. What is the ratio of the Employment to population ratio(%) in Papua New Guinea in 2003 to that in 2007?
Your answer should be compact. 1.01. What is the ratio of the Employment to population ratio(%) in Euro area in 2003 to that in 2008?
Offer a very short reply. 0.95. What is the ratio of the Employment to population ratio(%) of Malta in 2003 to that in 2008?
Make the answer very short. 1.1. What is the ratio of the Employment to population ratio(%) of Namibia in 2003 to that in 2008?
Provide a short and direct response. 1.35. What is the ratio of the Employment to population ratio(%) in Papua New Guinea in 2003 to that in 2008?
Offer a very short reply. 1.02. What is the ratio of the Employment to population ratio(%) of Euro area in 2003 to that in 2009?
Offer a terse response. 1.04. What is the ratio of the Employment to population ratio(%) of Malta in 2003 to that in 2009?
Your answer should be very brief. 1.17. What is the ratio of the Employment to population ratio(%) in Namibia in 2003 to that in 2009?
Give a very brief answer. 1.21. What is the ratio of the Employment to population ratio(%) in Papua New Guinea in 2003 to that in 2009?
Provide a short and direct response. 1.03. What is the ratio of the Employment to population ratio(%) of Euro area in 2003 to that in 2010?
Keep it short and to the point. 1.08. What is the ratio of the Employment to population ratio(%) of Malta in 2003 to that in 2010?
Your answer should be compact. 1.16. What is the ratio of the Employment to population ratio(%) of Namibia in 2003 to that in 2010?
Your answer should be compact. 1.12. What is the ratio of the Employment to population ratio(%) of Papua New Guinea in 2003 to that in 2010?
Offer a very short reply. 1.04. What is the ratio of the Employment to population ratio(%) in Euro area in 2004 to that in 2005?
Offer a terse response. 0.98. What is the ratio of the Employment to population ratio(%) in Malta in 2004 to that in 2005?
Offer a terse response. 1.04. What is the ratio of the Employment to population ratio(%) of Namibia in 2004 to that in 2005?
Your response must be concise. 0.95. What is the ratio of the Employment to population ratio(%) of Euro area in 2004 to that in 2006?
Your answer should be compact. 0.96. What is the ratio of the Employment to population ratio(%) in Malta in 2004 to that in 2006?
Provide a short and direct response. 1.04. What is the ratio of the Employment to population ratio(%) in Namibia in 2004 to that in 2006?
Provide a succinct answer. 0.99. What is the ratio of the Employment to population ratio(%) in Euro area in 2004 to that in 2007?
Keep it short and to the point. 0.94. What is the ratio of the Employment to population ratio(%) of Malta in 2004 to that in 2007?
Provide a short and direct response. 1. What is the ratio of the Employment to population ratio(%) in Namibia in 2004 to that in 2007?
Give a very brief answer. 0.88. What is the ratio of the Employment to population ratio(%) of Papua New Guinea in 2004 to that in 2007?
Ensure brevity in your answer.  1.01. What is the ratio of the Employment to population ratio(%) of Euro area in 2004 to that in 2008?
Your answer should be compact. 0.96. What is the ratio of the Employment to population ratio(%) in Namibia in 2004 to that in 2008?
Keep it short and to the point. 1.28. What is the ratio of the Employment to population ratio(%) of Papua New Guinea in 2004 to that in 2008?
Ensure brevity in your answer.  1.02. What is the ratio of the Employment to population ratio(%) of Euro area in 2004 to that in 2009?
Make the answer very short. 1.05. What is the ratio of the Employment to population ratio(%) in Malta in 2004 to that in 2009?
Ensure brevity in your answer.  1.06. What is the ratio of the Employment to population ratio(%) of Namibia in 2004 to that in 2009?
Offer a terse response. 1.14. What is the ratio of the Employment to population ratio(%) in Papua New Guinea in 2004 to that in 2009?
Your response must be concise. 1.03. What is the ratio of the Employment to population ratio(%) in Euro area in 2004 to that in 2010?
Keep it short and to the point. 1.09. What is the ratio of the Employment to population ratio(%) of Malta in 2004 to that in 2010?
Make the answer very short. 1.05. What is the ratio of the Employment to population ratio(%) in Namibia in 2004 to that in 2010?
Offer a terse response. 1.05. What is the ratio of the Employment to population ratio(%) of Papua New Guinea in 2004 to that in 2010?
Provide a succinct answer. 1.04. What is the ratio of the Employment to population ratio(%) in Euro area in 2005 to that in 2006?
Keep it short and to the point. 0.98. What is the ratio of the Employment to population ratio(%) of Namibia in 2005 to that in 2006?
Your answer should be very brief. 1.04. What is the ratio of the Employment to population ratio(%) in Papua New Guinea in 2005 to that in 2006?
Offer a very short reply. 1. What is the ratio of the Employment to population ratio(%) of Euro area in 2005 to that in 2007?
Give a very brief answer. 0.96. What is the ratio of the Employment to population ratio(%) of Namibia in 2005 to that in 2007?
Offer a very short reply. 0.93. What is the ratio of the Employment to population ratio(%) in Papua New Guinea in 2005 to that in 2007?
Your answer should be compact. 1.01. What is the ratio of the Employment to population ratio(%) in Euro area in 2005 to that in 2008?
Keep it short and to the point. 0.97. What is the ratio of the Employment to population ratio(%) in Malta in 2005 to that in 2008?
Offer a terse response. 0.96. What is the ratio of the Employment to population ratio(%) in Namibia in 2005 to that in 2008?
Give a very brief answer. 1.35. What is the ratio of the Employment to population ratio(%) of Papua New Guinea in 2005 to that in 2008?
Make the answer very short. 1.02. What is the ratio of the Employment to population ratio(%) in Euro area in 2005 to that in 2009?
Your answer should be very brief. 1.06. What is the ratio of the Employment to population ratio(%) of Malta in 2005 to that in 2009?
Provide a short and direct response. 1.02. What is the ratio of the Employment to population ratio(%) in Namibia in 2005 to that in 2009?
Provide a succinct answer. 1.2. What is the ratio of the Employment to population ratio(%) of Papua New Guinea in 2005 to that in 2009?
Your response must be concise. 1.03. What is the ratio of the Employment to population ratio(%) of Euro area in 2005 to that in 2010?
Provide a succinct answer. 1.1. What is the ratio of the Employment to population ratio(%) of Malta in 2005 to that in 2010?
Ensure brevity in your answer.  1.01. What is the ratio of the Employment to population ratio(%) of Namibia in 2005 to that in 2010?
Ensure brevity in your answer.  1.11. What is the ratio of the Employment to population ratio(%) in Papua New Guinea in 2005 to that in 2010?
Your response must be concise. 1.04. What is the ratio of the Employment to population ratio(%) of Euro area in 2006 to that in 2007?
Provide a succinct answer. 0.98. What is the ratio of the Employment to population ratio(%) of Namibia in 2006 to that in 2007?
Ensure brevity in your answer.  0.89. What is the ratio of the Employment to population ratio(%) in Namibia in 2006 to that in 2008?
Offer a terse response. 1.29. What is the ratio of the Employment to population ratio(%) in Euro area in 2006 to that in 2009?
Keep it short and to the point. 1.09. What is the ratio of the Employment to population ratio(%) of Malta in 2006 to that in 2009?
Make the answer very short. 1.02. What is the ratio of the Employment to population ratio(%) of Namibia in 2006 to that in 2009?
Ensure brevity in your answer.  1.16. What is the ratio of the Employment to population ratio(%) in Papua New Guinea in 2006 to that in 2009?
Your response must be concise. 1.03. What is the ratio of the Employment to population ratio(%) of Euro area in 2006 to that in 2010?
Provide a short and direct response. 1.13. What is the ratio of the Employment to population ratio(%) in Malta in 2006 to that in 2010?
Give a very brief answer. 1.01. What is the ratio of the Employment to population ratio(%) of Namibia in 2006 to that in 2010?
Keep it short and to the point. 1.07. What is the ratio of the Employment to population ratio(%) in Papua New Guinea in 2006 to that in 2010?
Provide a short and direct response. 1.04. What is the ratio of the Employment to population ratio(%) of Euro area in 2007 to that in 2008?
Provide a short and direct response. 1.01. What is the ratio of the Employment to population ratio(%) in Namibia in 2007 to that in 2008?
Your answer should be compact. 1.46. What is the ratio of the Employment to population ratio(%) of Papua New Guinea in 2007 to that in 2008?
Your response must be concise. 1.01. What is the ratio of the Employment to population ratio(%) in Euro area in 2007 to that in 2009?
Make the answer very short. 1.11. What is the ratio of the Employment to population ratio(%) in Malta in 2007 to that in 2009?
Your response must be concise. 1.06. What is the ratio of the Employment to population ratio(%) of Namibia in 2007 to that in 2009?
Offer a terse response. 1.3. What is the ratio of the Employment to population ratio(%) of Papua New Guinea in 2007 to that in 2009?
Give a very brief answer. 1.02. What is the ratio of the Employment to population ratio(%) in Euro area in 2007 to that in 2010?
Ensure brevity in your answer.  1.15. What is the ratio of the Employment to population ratio(%) in Malta in 2007 to that in 2010?
Keep it short and to the point. 1.05. What is the ratio of the Employment to population ratio(%) in Namibia in 2007 to that in 2010?
Your response must be concise. 1.2. What is the ratio of the Employment to population ratio(%) in Papua New Guinea in 2007 to that in 2010?
Provide a short and direct response. 1.03. What is the ratio of the Employment to population ratio(%) in Euro area in 2008 to that in 2009?
Make the answer very short. 1.1. What is the ratio of the Employment to population ratio(%) in Malta in 2008 to that in 2009?
Provide a short and direct response. 1.06. What is the ratio of the Employment to population ratio(%) in Namibia in 2008 to that in 2009?
Give a very brief answer. 0.89. What is the ratio of the Employment to population ratio(%) of Euro area in 2008 to that in 2010?
Your answer should be very brief. 1.14. What is the ratio of the Employment to population ratio(%) of Malta in 2008 to that in 2010?
Make the answer very short. 1.05. What is the ratio of the Employment to population ratio(%) of Namibia in 2008 to that in 2010?
Provide a succinct answer. 0.83. What is the ratio of the Employment to population ratio(%) of Papua New Guinea in 2008 to that in 2010?
Keep it short and to the point. 1.02. What is the ratio of the Employment to population ratio(%) in Euro area in 2009 to that in 2010?
Keep it short and to the point. 1.04. What is the ratio of the Employment to population ratio(%) in Namibia in 2009 to that in 2010?
Give a very brief answer. 0.92. What is the ratio of the Employment to population ratio(%) in Papua New Guinea in 2009 to that in 2010?
Your answer should be compact. 1.01. What is the difference between the highest and the second highest Employment to population ratio(%) of Euro area?
Your answer should be very brief. 0.46. What is the difference between the highest and the lowest Employment to population ratio(%) in Euro area?
Make the answer very short. 5.44. What is the difference between the highest and the lowest Employment to population ratio(%) in Malta?
Offer a very short reply. 7.6. What is the difference between the highest and the lowest Employment to population ratio(%) of Namibia?
Provide a short and direct response. 8.4. What is the difference between the highest and the lowest Employment to population ratio(%) of Papua New Guinea?
Give a very brief answer. 2.2. 